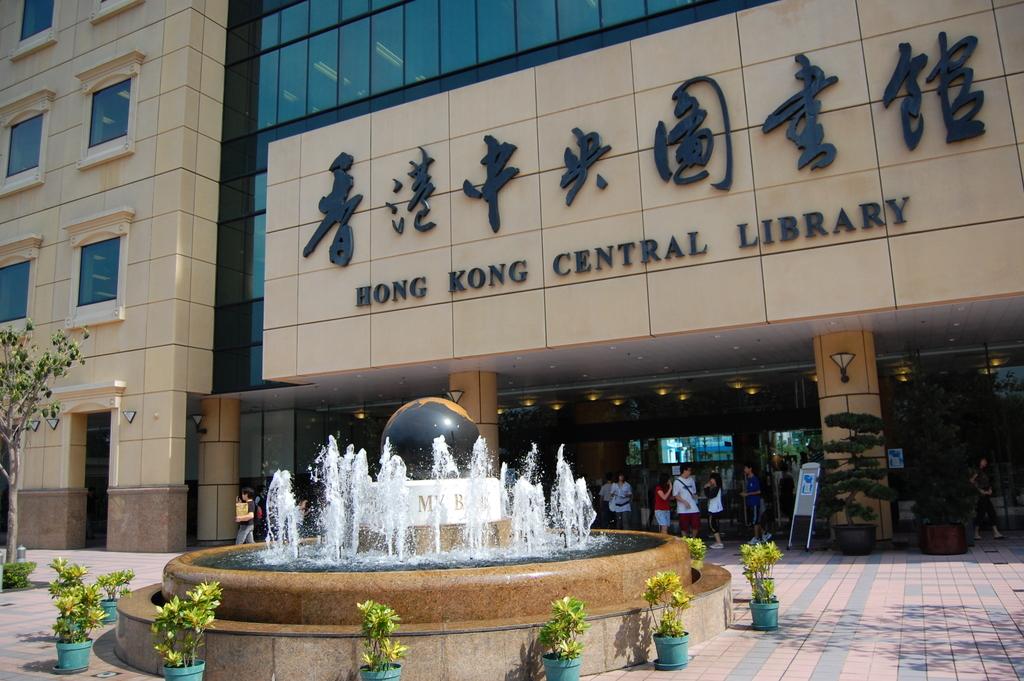Where is this library?
Offer a very short reply. Hong kong. Wht kind of building is this?
Provide a short and direct response. Library. 